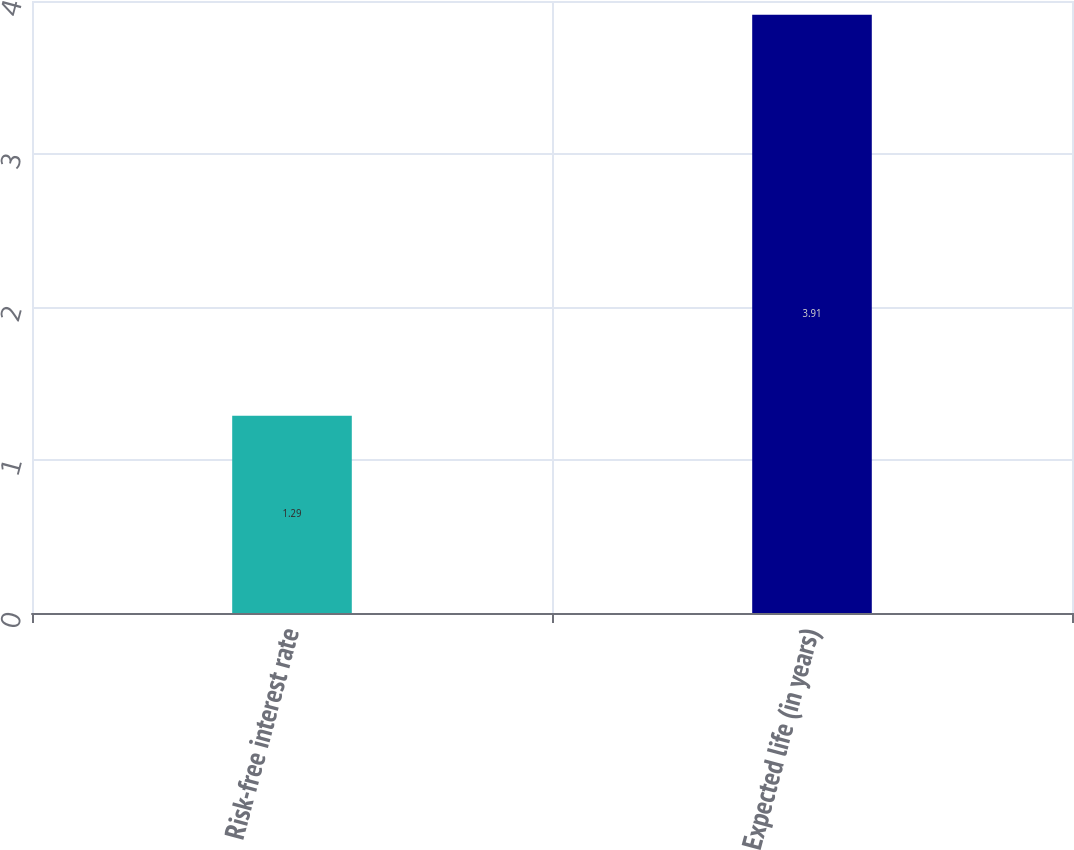Convert chart to OTSL. <chart><loc_0><loc_0><loc_500><loc_500><bar_chart><fcel>Risk-free interest rate<fcel>Expected life (in years)<nl><fcel>1.29<fcel>3.91<nl></chart> 